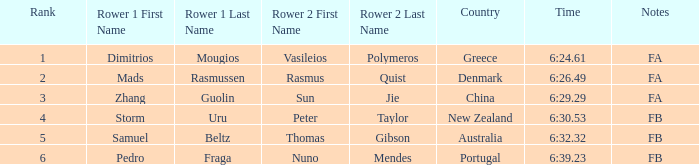What country has a rank smaller than 6, a time of 6:32.32 and notes of FB? Australia. Could you parse the entire table? {'header': ['Rank', 'Rower 1 First Name', 'Rower 1 Last Name', 'Rower 2 First Name', 'Rower 2 Last Name', 'Country', 'Time', 'Notes'], 'rows': [['1', 'Dimitrios', 'Mougios', 'Vasileios', 'Polymeros', 'Greece', '6:24.61', 'FA'], ['2', 'Mads', 'Rasmussen', 'Rasmus', 'Quist', 'Denmark', '6:26.49', 'FA'], ['3', 'Zhang', 'Guolin', 'Sun', 'Jie', 'China', '6:29.29', 'FA'], ['4', 'Storm', 'Uru', 'Peter', 'Taylor', 'New Zealand', '6:30.53', 'FB'], ['5', 'Samuel', 'Beltz', 'Thomas', 'Gibson', 'Australia', '6:32.32', 'FB'], ['6', 'Pedro', 'Fraga', 'Nuno', 'Mendes', 'Portugal', '6:39.23', 'FB']]} 